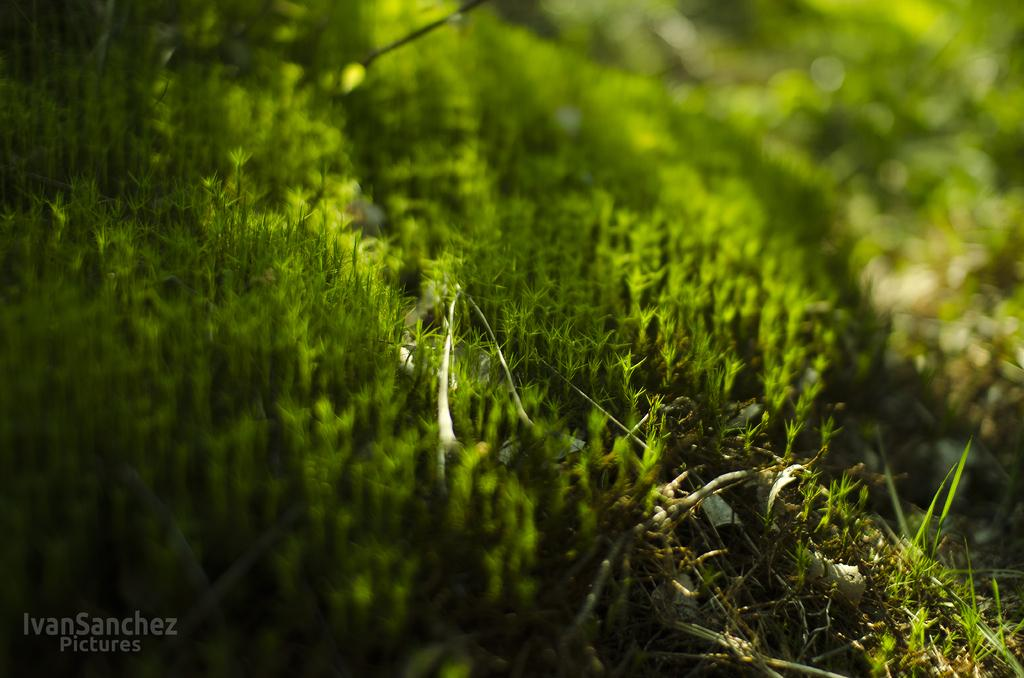What type of living organisms can be seen in the image? Plants can be seen on the ground in the image. Is there any text present in the image? Yes, there is some text visible in the bottom left corner of the image. What type of yoke is being used to carry the plants in the image? There is no yoke present in the image, and the plants are not being carried. 